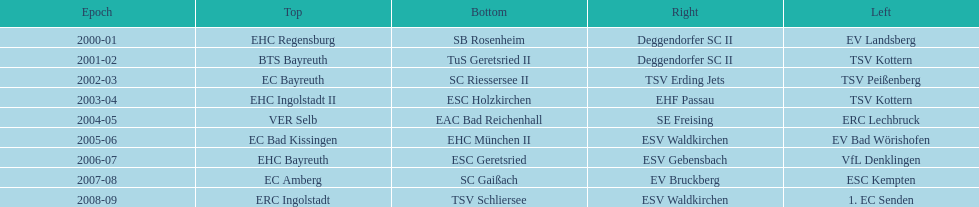The last team to win the west? 1. EC Senden. 